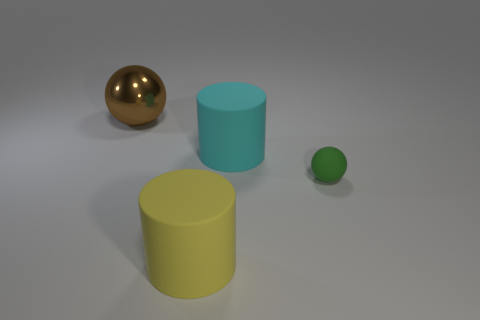Add 1 tiny green rubber spheres. How many objects exist? 5 Subtract 0 gray spheres. How many objects are left? 4 Subtract all big cyan matte objects. Subtract all small rubber cylinders. How many objects are left? 3 Add 3 tiny objects. How many tiny objects are left? 4 Add 1 brown things. How many brown things exist? 2 